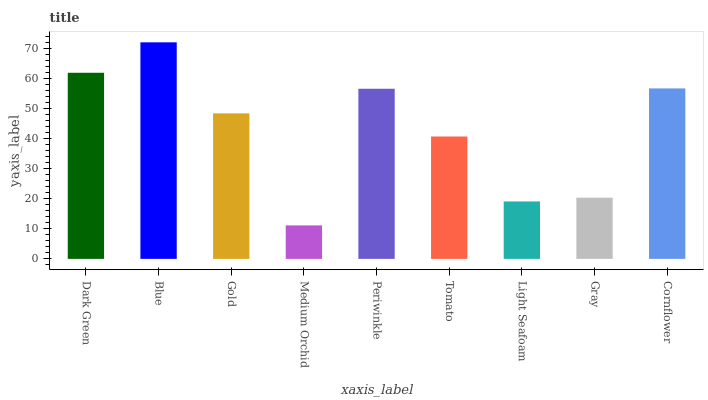Is Medium Orchid the minimum?
Answer yes or no. Yes. Is Blue the maximum?
Answer yes or no. Yes. Is Gold the minimum?
Answer yes or no. No. Is Gold the maximum?
Answer yes or no. No. Is Blue greater than Gold?
Answer yes or no. Yes. Is Gold less than Blue?
Answer yes or no. Yes. Is Gold greater than Blue?
Answer yes or no. No. Is Blue less than Gold?
Answer yes or no. No. Is Gold the high median?
Answer yes or no. Yes. Is Gold the low median?
Answer yes or no. Yes. Is Tomato the high median?
Answer yes or no. No. Is Dark Green the low median?
Answer yes or no. No. 